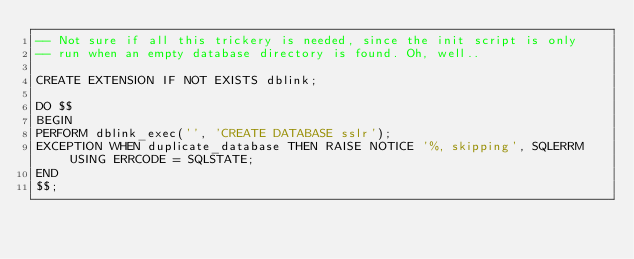<code> <loc_0><loc_0><loc_500><loc_500><_SQL_>-- Not sure if all this trickery is needed, since the init script is only
-- run when an empty database directory is found. Oh, well..

CREATE EXTENSION IF NOT EXISTS dblink;

DO $$
BEGIN
PERFORM dblink_exec('', 'CREATE DATABASE sslr');
EXCEPTION WHEN duplicate_database THEN RAISE NOTICE '%, skipping', SQLERRM USING ERRCODE = SQLSTATE;
END
$$;
</code> 